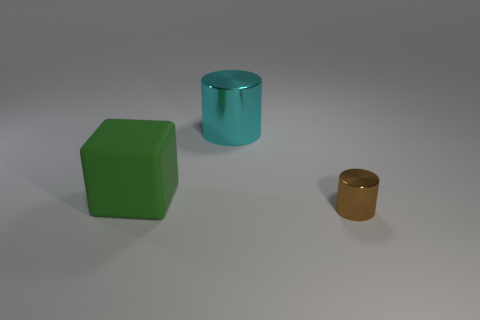Is there any other thing that has the same size as the brown metallic cylinder?
Give a very brief answer. No. How many other green matte cubes are the same size as the green block?
Give a very brief answer. 0. Are there an equal number of big cubes in front of the tiny brown object and metallic objects that are right of the cyan cylinder?
Your response must be concise. No. Is the small cylinder made of the same material as the large cyan cylinder?
Your answer should be very brief. Yes. There is a brown object that is on the right side of the green matte thing; are there any blocks that are behind it?
Your response must be concise. Yes. Are there any other cyan shiny objects of the same shape as the tiny metal thing?
Give a very brief answer. Yes. What is the material of the object on the right side of the big thing right of the big green rubber block?
Offer a very short reply. Metal. What is the size of the brown metallic cylinder?
Provide a succinct answer. Small. What size is the brown object that is the same material as the cyan cylinder?
Offer a very short reply. Small. There is a thing behind the green rubber block; does it have the same size as the big block?
Ensure brevity in your answer.  Yes. 